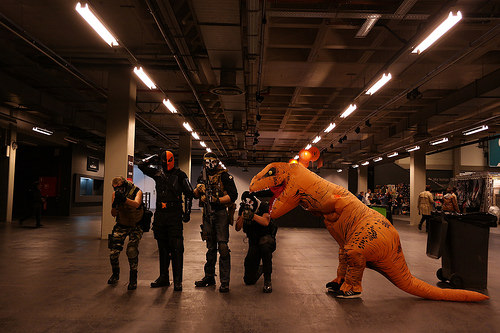<image>
Is the dinosaur on the ninja? Yes. Looking at the image, I can see the dinosaur is positioned on top of the ninja, with the ninja providing support. Is there a dinosaur behind the man? No. The dinosaur is not behind the man. From this viewpoint, the dinosaur appears to be positioned elsewhere in the scene. 